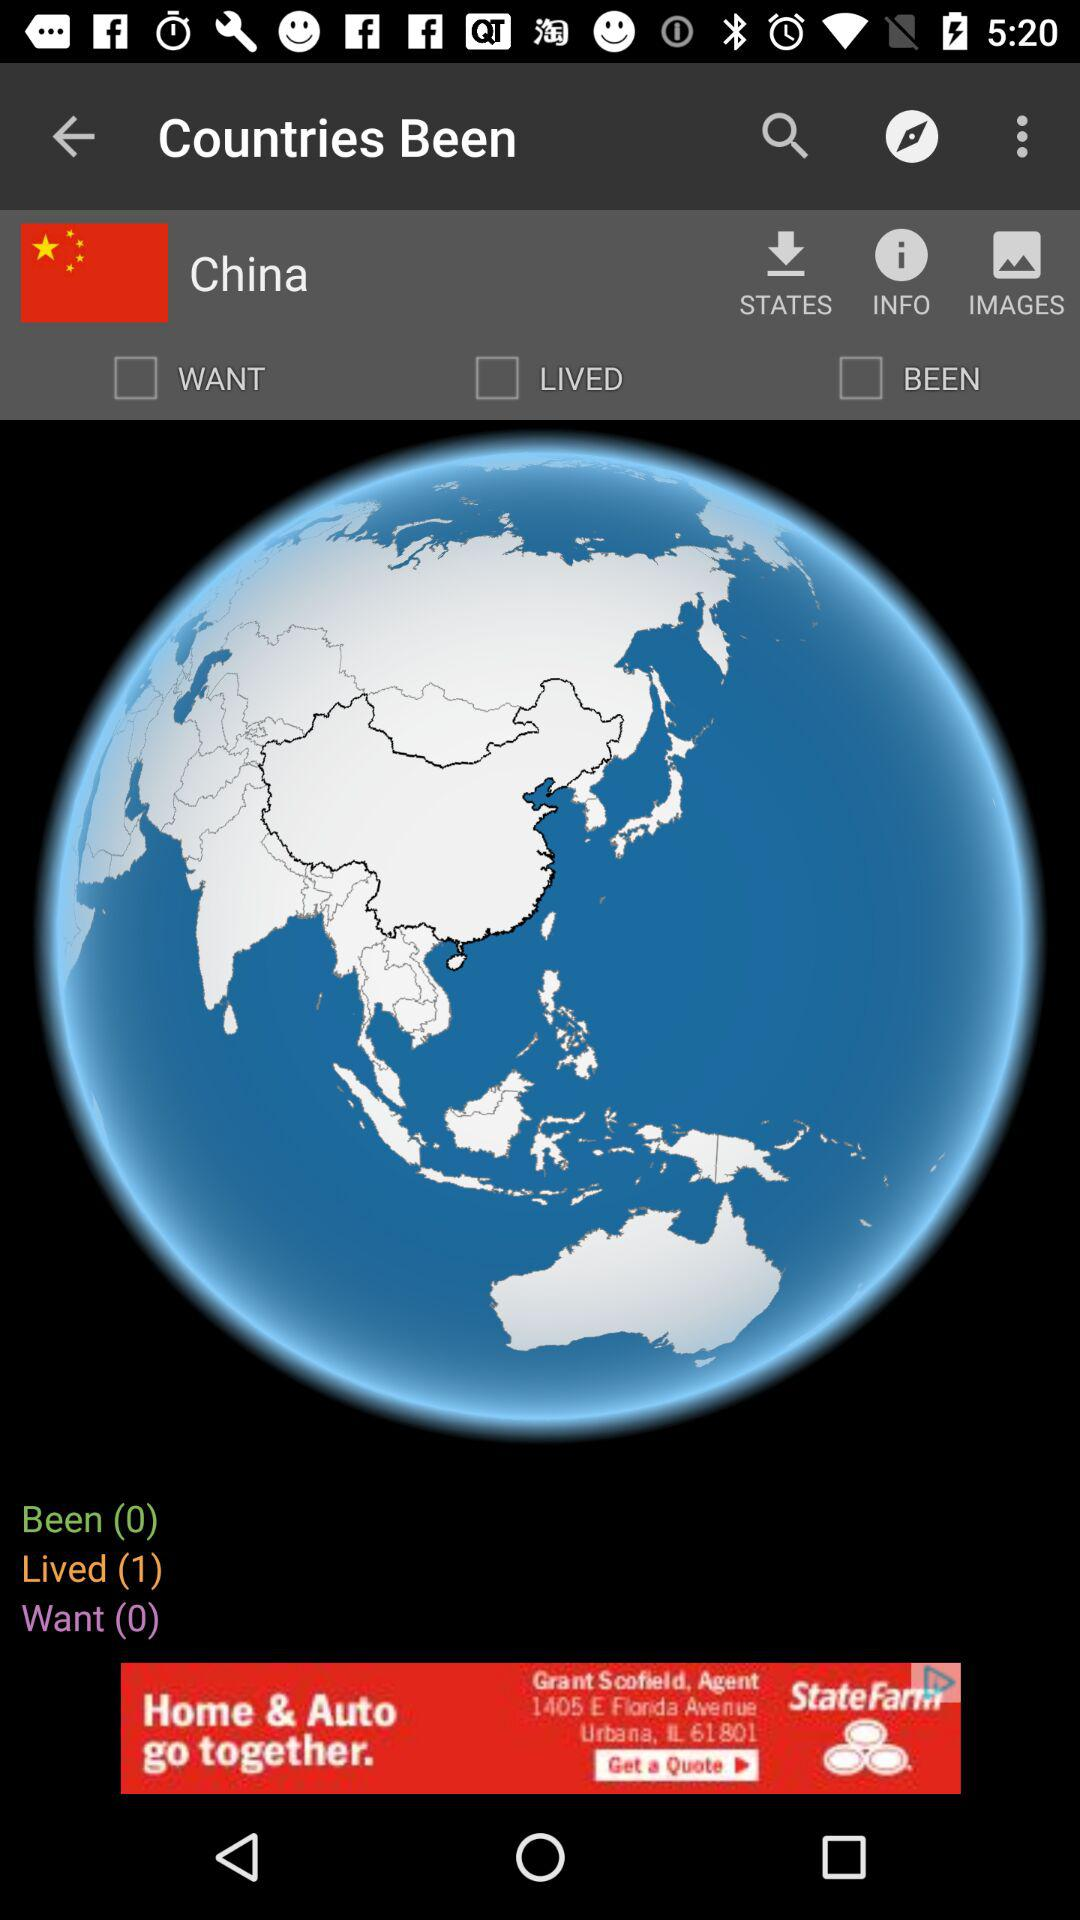How many of the countries have I lived in?
Answer the question using a single word or phrase. 1 